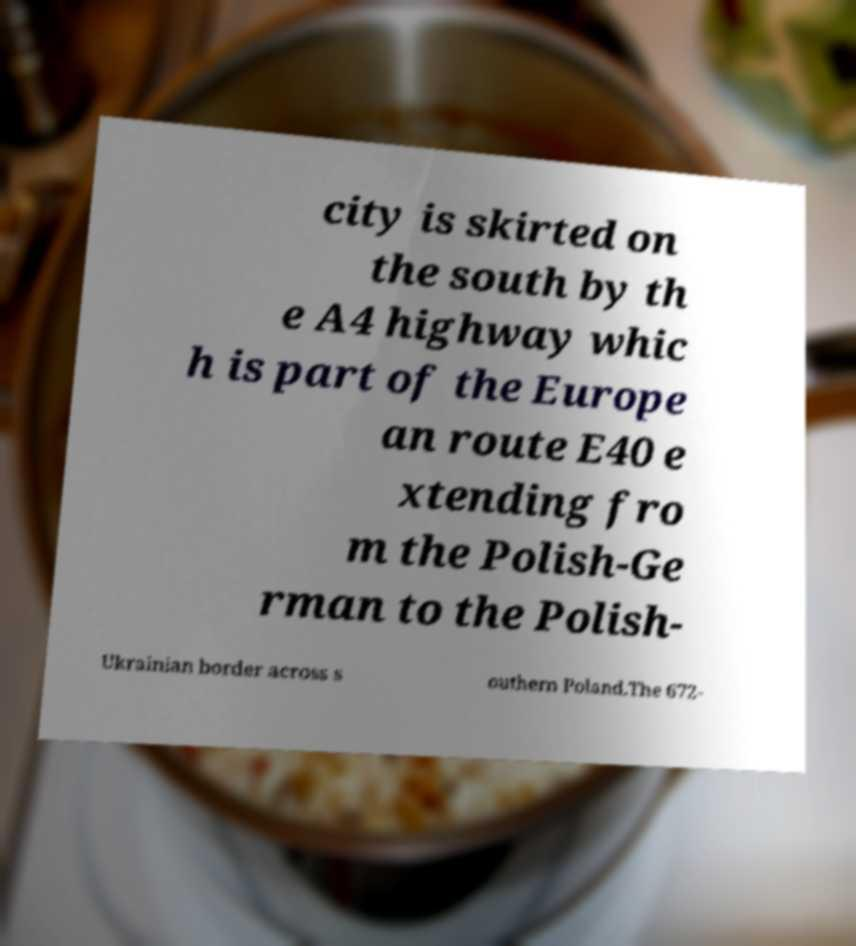Please identify and transcribe the text found in this image. city is skirted on the south by th e A4 highway whic h is part of the Europe an route E40 e xtending fro m the Polish-Ge rman to the Polish- Ukrainian border across s outhern Poland.The 672- 